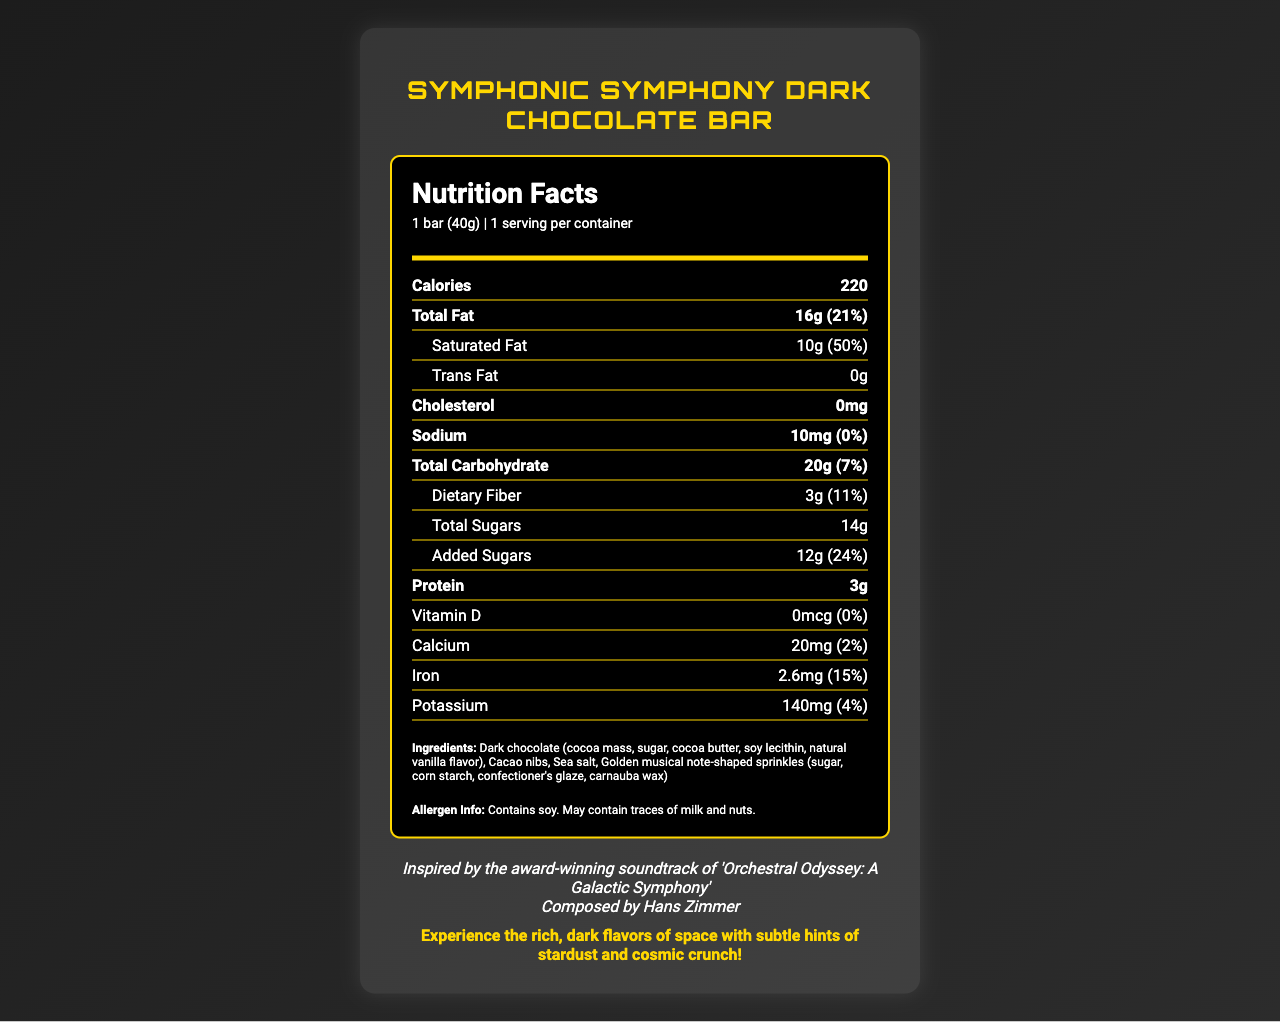What is the serving size of the Symphonic Symphony Dark Chocolate Bar? The serving size is listed as "1 bar (40g)" at the top of the nutrition facts section.
Answer: 1 bar (40g) How many total calories are in one serving of this chocolate bar? The document states that there are 220 calories per serving.
Answer: 220 What percentage of daily value does the total fat content in the chocolate bar represent? The total fat content is 16g, which represents 21% of the daily value.
Answer: 21% Who is the composer associated with the chocolate bar's movie inspiration? The document mentions that Hans Zimmer is the composer associated with the movie "Orchestral Odyssey: A Galactic Symphony."
Answer: Hans Zimmer How much protein is contained in each serving of the chocolate bar? According to the nutrition facts, each serving contains 3g of protein.
Answer: 3g Which of the following ingredients is NOT listed in the chocolate bar: A. Soy lecithin, B. Sea salt, C. Cream, D. Natural vanilla flavor Cream is not listed as one of the ingredients in the chocolate bar, whereas soy lecithin, sea salt, and natural vanilla flavor are listed.
Answer: C. Cream How much iron does the Symphonic Symphony Dark Chocolate Bar contain? A. 0.5mg, B. 2.6mg, C. 10mg, D. 20mg The document shows that the chocolate bar contains 2.6mg of iron.
Answer: B. 2.6mg Does the Symphonic Symphony Dark Chocolate Bar contain any trans fat? The nutrition facts mention that the chocolate bar contains 0g of trans fat.
Answer: No Describe the main idea of this document. The document covers all essential aspects of the chocolate bar's nutrition facts and connects it to its movie inspiration and promotional theme.
Answer: The document provides detailed nutritional information for a limited edition Symphonic Symphony Dark Chocolate Bar inspired by the award-winning soundtrack of the movie "Orchestral Odyssey: A Galactic Symphony," composed by Hans Zimmer. It includes specific details about serving size, calories, fat content, sodium, carbohydrates, sugars, protein, vitamins, minerals, ingredients, allergen information, and promotional text that connects the product to its space-themed inspiration. What is the main ingredient in the Symphonic Symphony Dark Chocolate Bar? The first ingredient listed is "Dark chocolate (cocoa mass, sugar, cocoa butter, soy lecithin, natural vanilla flavor)," indicating that dark chocolate is the main ingredient.
Answer: Dark chocolate Where is the manufacturer of the chocolate bar located? The address given for the manufacturer, Cinematic Confections, Inc., is "123 Hollywood Blvd, Los Angeles, CA 90028."
Answer: 123 Hollywood Blvd, Los Angeles, CA 90028 Can the calcium content of the chocolate bar be considered as high? The calcium content is only 20mg, which accounts for 2% of the daily value, indicating that it is low.
Answer: No What are the golden musical note-shaped sprinkles made of? The document lists the ingredients of the sprinkles as "sugar, corn starch, confectioner's glaze, carnauba wax."
Answer: Sugar, corn starch, confectioner's glaze, carnauba wax What are the promotional text contents for the chocolate bar? The promotional text is displayed at the bottom of the document in bold and gold color.
Answer: "Experience the rich, dark flavors of space with subtle hints of stardust and cosmic crunch!" What is the sugar content of the chocolate bar? The document specifies that the chocolate bar contains 14g of total sugars and 12g of added sugars.
Answer: 14g total sugars, 12g added sugars Is the Symphonic Symphony Dark Chocolate Bar suitable for someone with a soy allergy? The document states that the product contains soy.
Answer: No How many servings are there in each container of the chocolate bar? The nutrition facts mention that there is 1 serving per container.
Answer: 1 Can it be determined if the chocolate bar is gluten-free? The document does not provide sufficient information to determine whether the chocolate bar is gluten-free.
Answer: Not enough information 